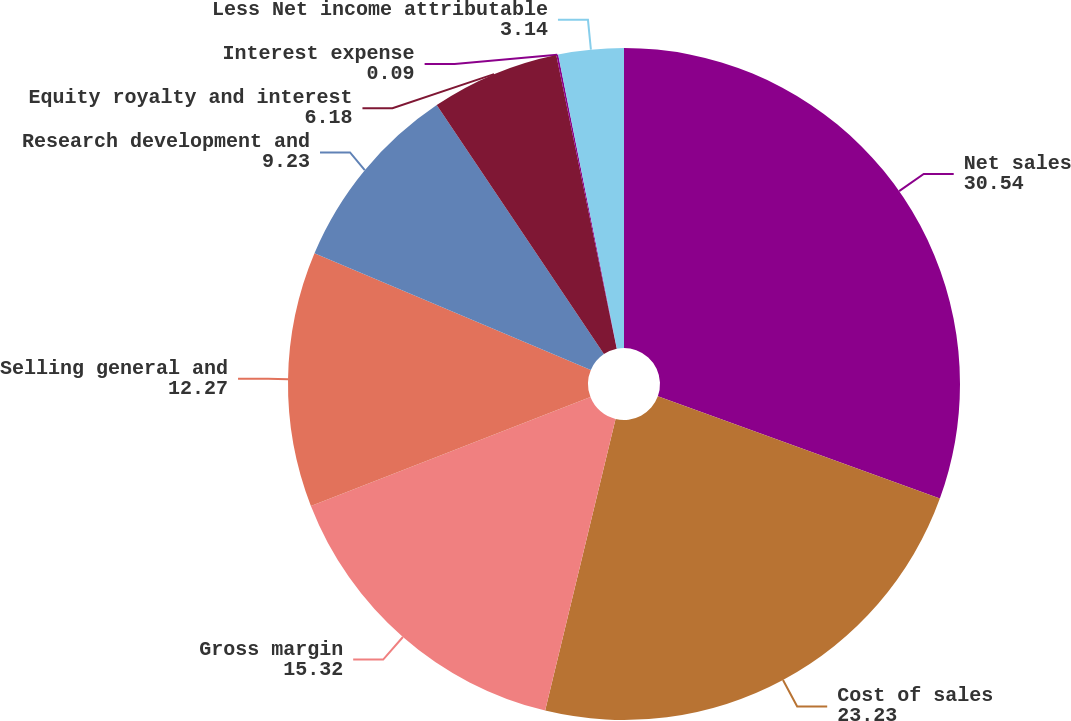Convert chart to OTSL. <chart><loc_0><loc_0><loc_500><loc_500><pie_chart><fcel>Net sales<fcel>Cost of sales<fcel>Gross margin<fcel>Selling general and<fcel>Research development and<fcel>Equity royalty and interest<fcel>Interest expense<fcel>Less Net income attributable<nl><fcel>30.54%<fcel>23.23%<fcel>15.32%<fcel>12.27%<fcel>9.23%<fcel>6.18%<fcel>0.09%<fcel>3.14%<nl></chart> 